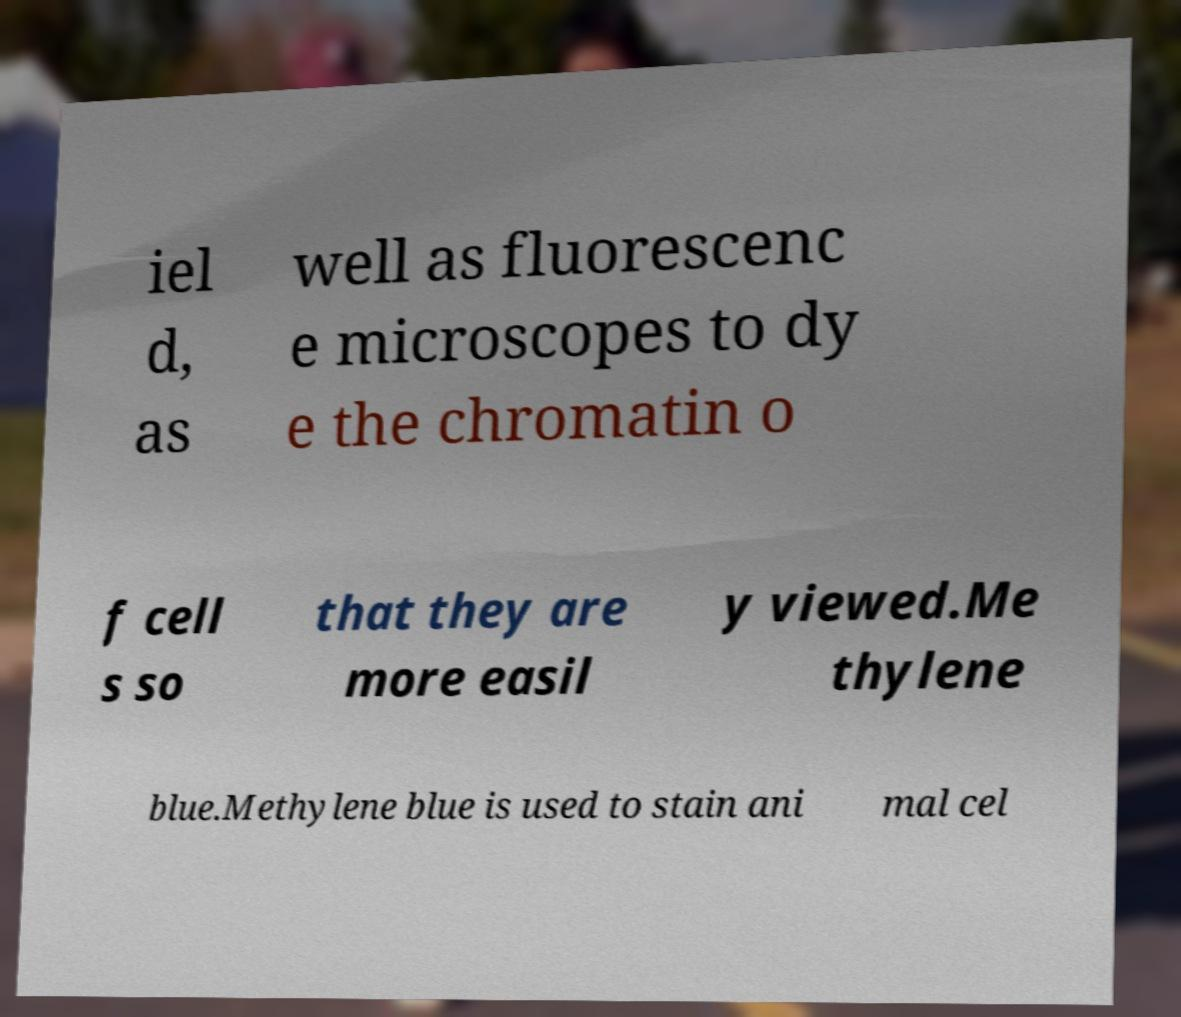Please identify and transcribe the text found in this image. iel d, as well as fluorescenc e microscopes to dy e the chromatin o f cell s so that they are more easil y viewed.Me thylene blue.Methylene blue is used to stain ani mal cel 